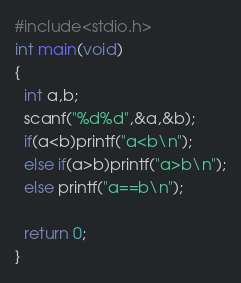Convert code to text. <code><loc_0><loc_0><loc_500><loc_500><_C_>#include<stdio.h>
int main(void)
{
  int a,b;
  scanf("%d%d",&a,&b);
  if(a<b)printf("a<b\n");
  else if(a>b)printf("a>b\n");
  else printf("a==b\n");

  return 0;
}
</code> 